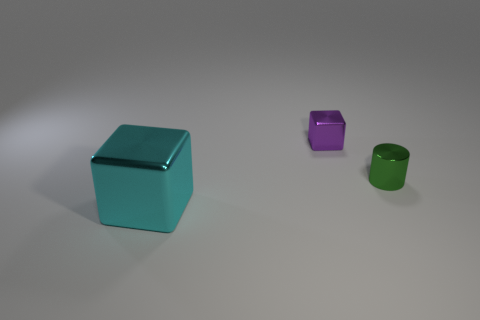What is the material of the other object that is the same shape as the small purple object?
Your answer should be compact. Metal. There is a cube right of the block to the left of the shiny block to the right of the cyan shiny object; how big is it?
Offer a terse response. Small. There is a large cyan object; are there any green metal cylinders in front of it?
Provide a short and direct response. No. There is a purple object that is the same material as the small green cylinder; what is its size?
Your answer should be compact. Small. What number of tiny objects have the same shape as the large cyan object?
Ensure brevity in your answer.  1. Do the small cylinder and the block to the right of the big cyan thing have the same material?
Provide a succinct answer. Yes. Are there more purple objects that are on the left side of the big metallic block than large yellow metallic objects?
Offer a terse response. No. Is there a large blue block that has the same material as the cylinder?
Offer a very short reply. No. Are the object to the left of the tiny purple thing and the cube that is behind the cyan metal cube made of the same material?
Your answer should be compact. Yes. Is the number of tiny cylinders that are to the left of the small cube the same as the number of big cyan metallic things in front of the large block?
Offer a terse response. Yes. 